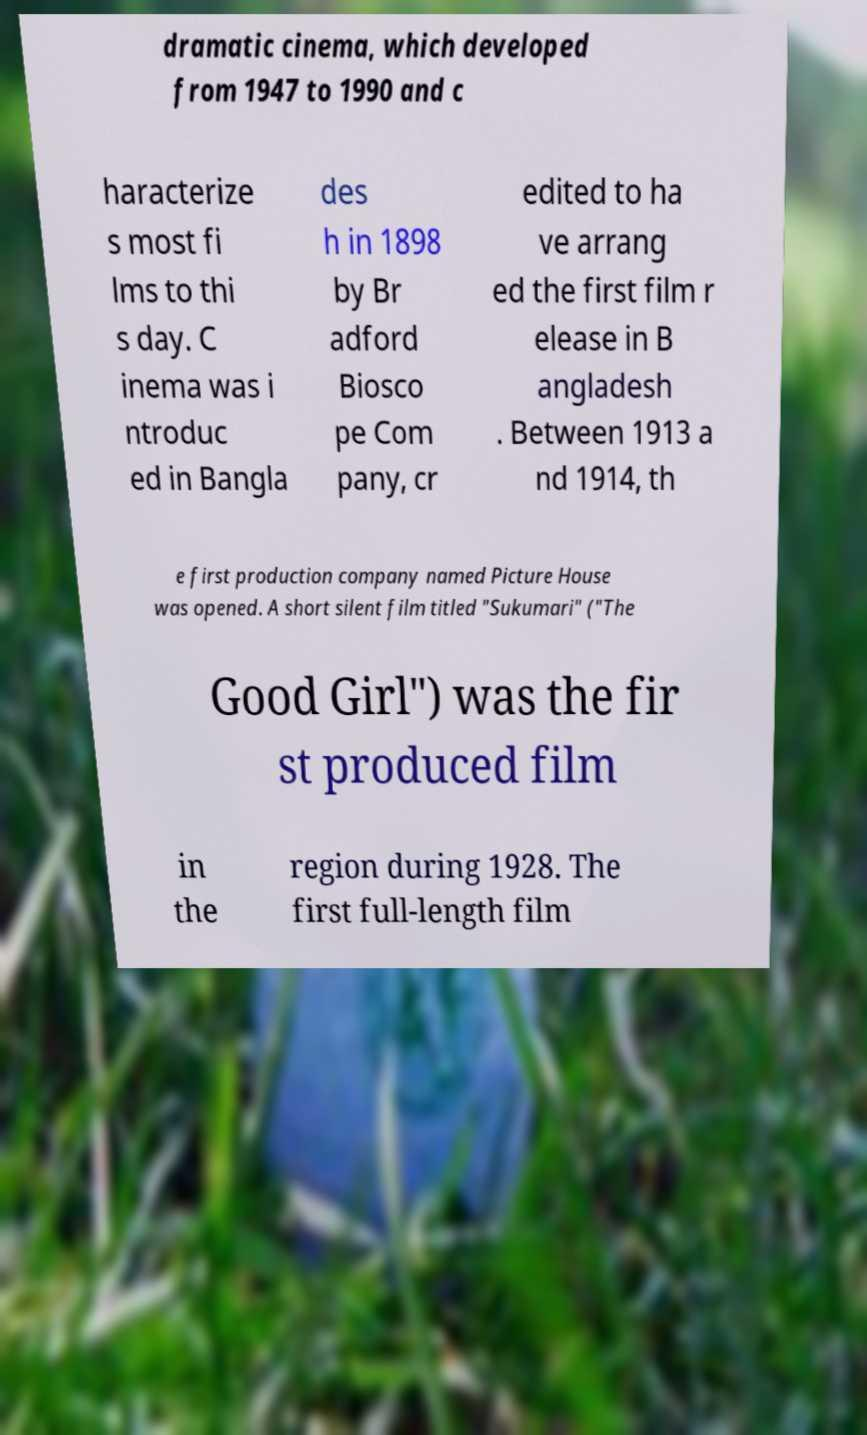Can you read and provide the text displayed in the image?This photo seems to have some interesting text. Can you extract and type it out for me? dramatic cinema, which developed from 1947 to 1990 and c haracterize s most fi lms to thi s day. C inema was i ntroduc ed in Bangla des h in 1898 by Br adford Biosco pe Com pany, cr edited to ha ve arrang ed the first film r elease in B angladesh . Between 1913 a nd 1914, th e first production company named Picture House was opened. A short silent film titled "Sukumari" ("The Good Girl") was the fir st produced film in the region during 1928. The first full-length film 